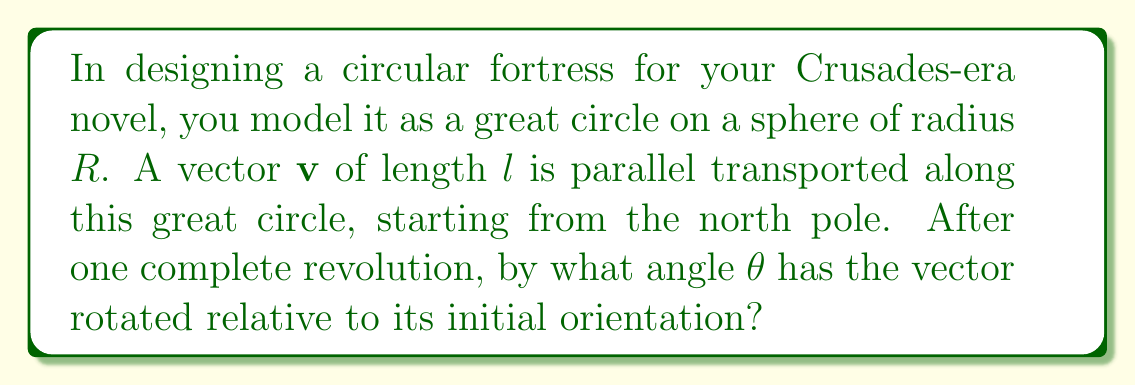Solve this math problem. 1) In spherical geometry, parallel transport along a closed curve results in a rotation of the vector. This rotation is related to the solid angle enclosed by the curve.

2) For a great circle on a sphere, the enclosed solid angle is $2\pi$ steradians.

3) The general formula for the rotation angle $\theta$ after parallel transport on a sphere is:

   $$\theta = \Omega$$

   where $\Omega$ is the solid angle enclosed by the curve.

4) Therefore, for our great circle:

   $$\theta = 2\pi$$

5) This means the vector will rotate by a full $2\pi$ radians, or 360°, after one complete revolution around the great circle.

6) Note that this result is independent of the radius $R$ of the sphere and the length $l$ of the vector, which is a fundamental property of parallel transport on a sphere.
Answer: $2\pi$ radians 